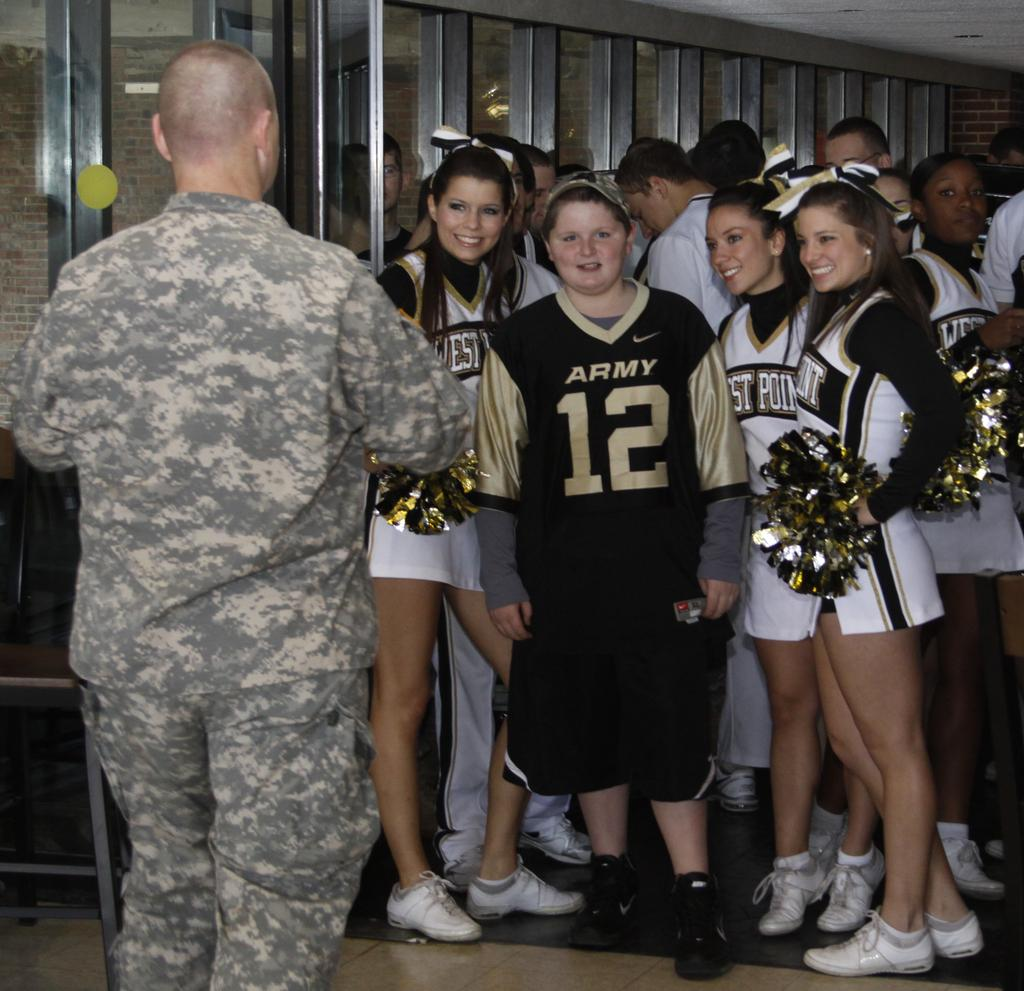<image>
Share a concise interpretation of the image provided. a military person is speaking to a group of cheerleaders and a girl in an Army jersey at west point 